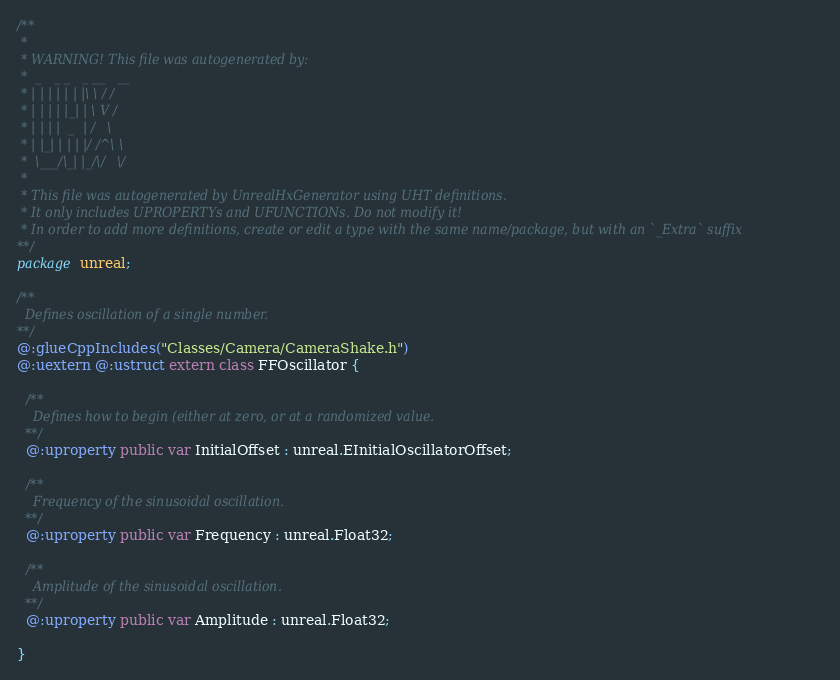Convert code to text. <code><loc_0><loc_0><loc_500><loc_500><_Haxe_>/**
 * 
 * WARNING! This file was autogenerated by: 
 *  _   _ _   _ __   __ 
 * | | | | | | |\ \ / / 
 * | | | | |_| | \ V /  
 * | | | |  _  | /   \  
 * | |_| | | | |/ /^\ \ 
 *  \___/\_| |_/\/   \/ 
 * 
 * This file was autogenerated by UnrealHxGenerator using UHT definitions.
 * It only includes UPROPERTYs and UFUNCTIONs. Do not modify it!
 * In order to add more definitions, create or edit a type with the same name/package, but with an `_Extra` suffix
**/
package unreal;

/**
  Defines oscillation of a single number.
**/
@:glueCppIncludes("Classes/Camera/CameraShake.h")
@:uextern @:ustruct extern class FFOscillator {
  
  /**
    Defines how to begin (either at zero, or at a randomized value.
  **/
  @:uproperty public var InitialOffset : unreal.EInitialOscillatorOffset;
  
  /**
    Frequency of the sinusoidal oscillation.
  **/
  @:uproperty public var Frequency : unreal.Float32;
  
  /**
    Amplitude of the sinusoidal oscillation.
  **/
  @:uproperty public var Amplitude : unreal.Float32;
  
}
</code> 